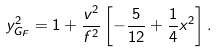Convert formula to latex. <formula><loc_0><loc_0><loc_500><loc_500>y ^ { 2 } _ { G _ { F } } = 1 + \frac { v ^ { 2 } } { f ^ { 2 } } \left [ - \frac { 5 } { 1 2 } + \frac { 1 } { 4 } x ^ { 2 } \right ] .</formula> 